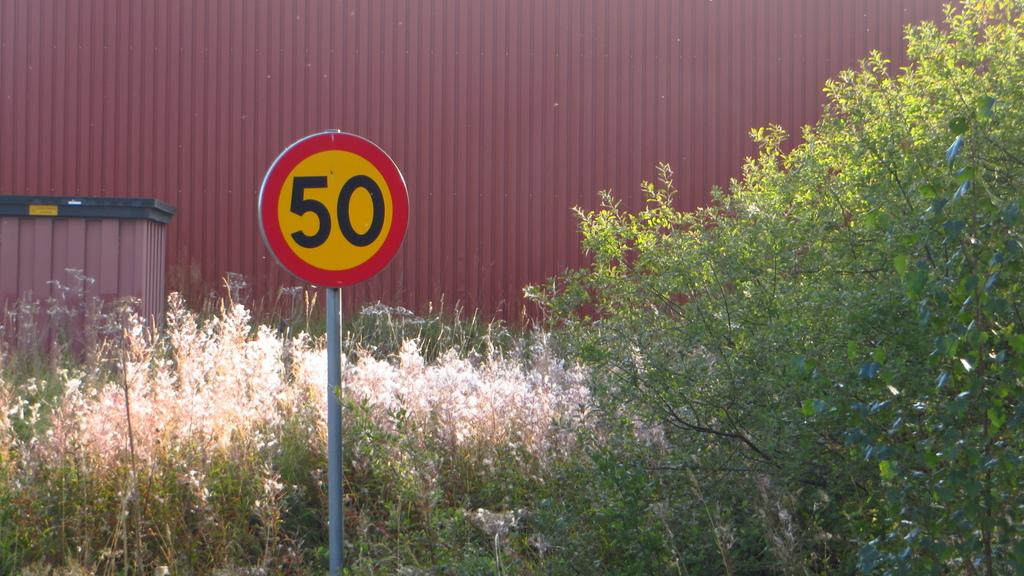<image>
Create a compact narrative representing the image presented. A yellow street sign labeled "50" stands in front of some weeds and a warehouse. 